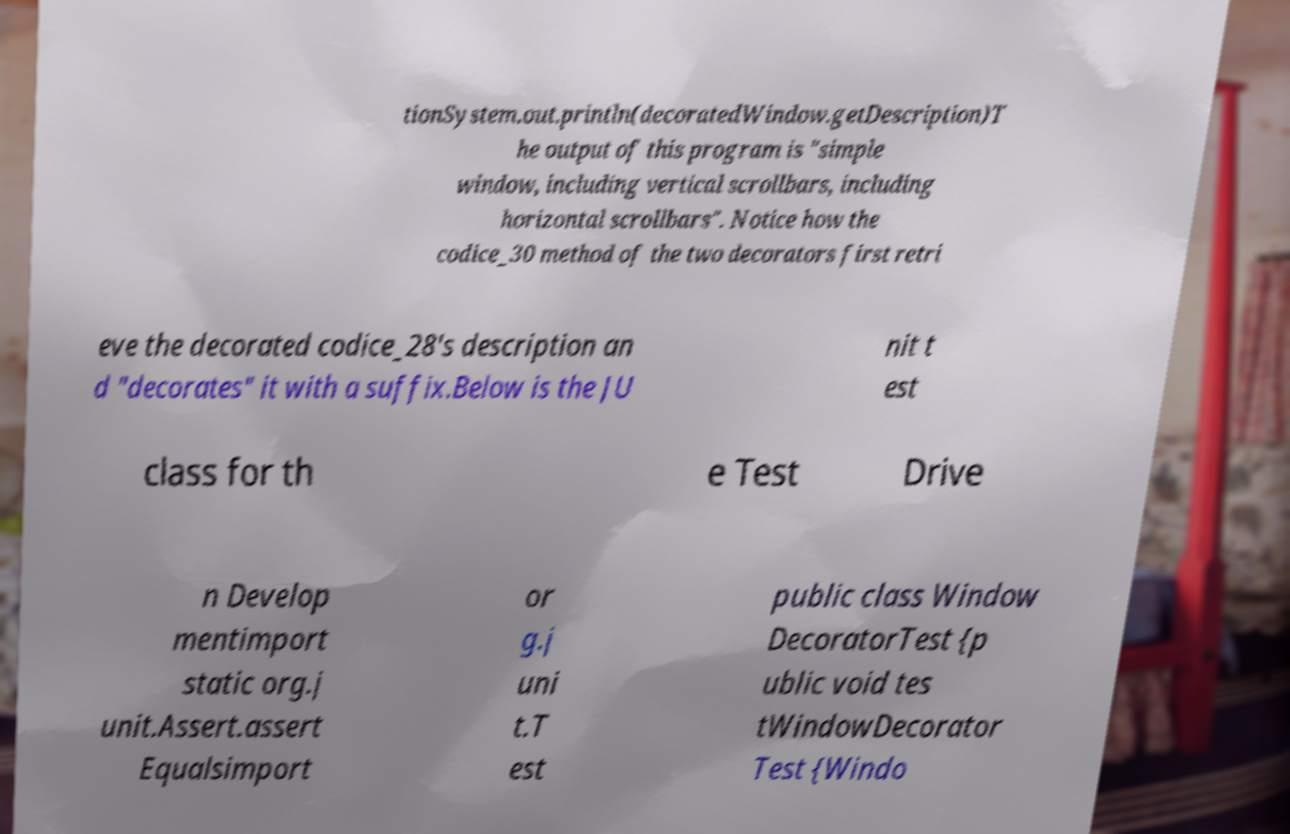Could you assist in decoding the text presented in this image and type it out clearly? tionSystem.out.println(decoratedWindow.getDescription)T he output of this program is "simple window, including vertical scrollbars, including horizontal scrollbars". Notice how the codice_30 method of the two decorators first retri eve the decorated codice_28's description an d "decorates" it with a suffix.Below is the JU nit t est class for th e Test Drive n Develop mentimport static org.j unit.Assert.assert Equalsimport or g.j uni t.T est public class Window DecoratorTest {p ublic void tes tWindowDecorator Test {Windo 